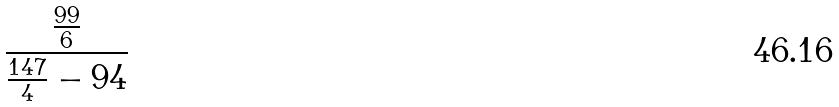<formula> <loc_0><loc_0><loc_500><loc_500>\frac { \frac { 9 9 } { 6 } } { \frac { 1 4 7 } { 4 } - 9 4 }</formula> 